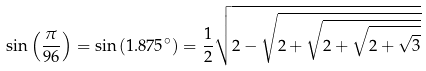<formula> <loc_0><loc_0><loc_500><loc_500>\sin \left ( { \frac { \pi } { 9 6 } } \right ) = \sin \left ( 1 . 8 7 5 ^ { \circ } \right ) = { \frac { 1 } { 2 } } { \sqrt { 2 - { \sqrt { 2 + { \sqrt { 2 + { \sqrt { 2 + { \sqrt { 3 } } } } } } } } } }</formula> 